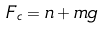Convert formula to latex. <formula><loc_0><loc_0><loc_500><loc_500>F _ { c } = n + m g</formula> 